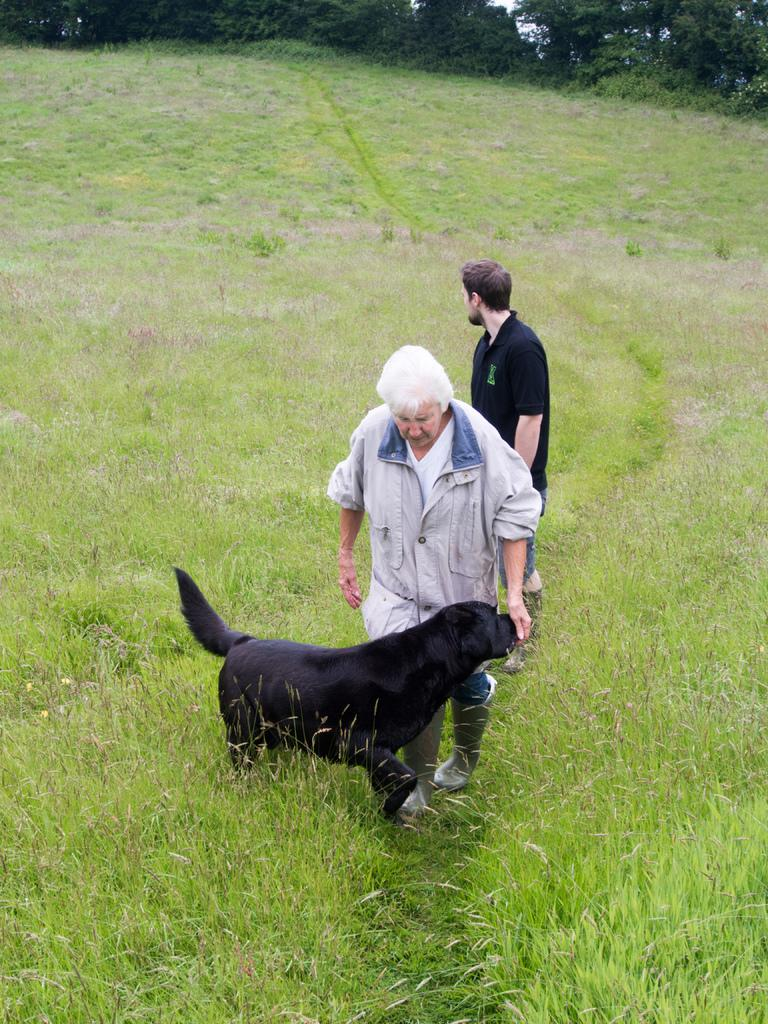How many people are in the image? There are two persons in the image. What is one person doing with an animal in the image? One person is holding a dog in the image. What type of vegetation can be seen in the image? There are trees in the image. What is the ground covered with in the image? The ground is covered with grass in the image. What part of the natural environment is visible in the image? The sky is visible in the image. What type of discussion is taking place between the persons and the notebook in the image? There is no notebook present in the image, and therefore no discussion involving a notebook can be observed. 